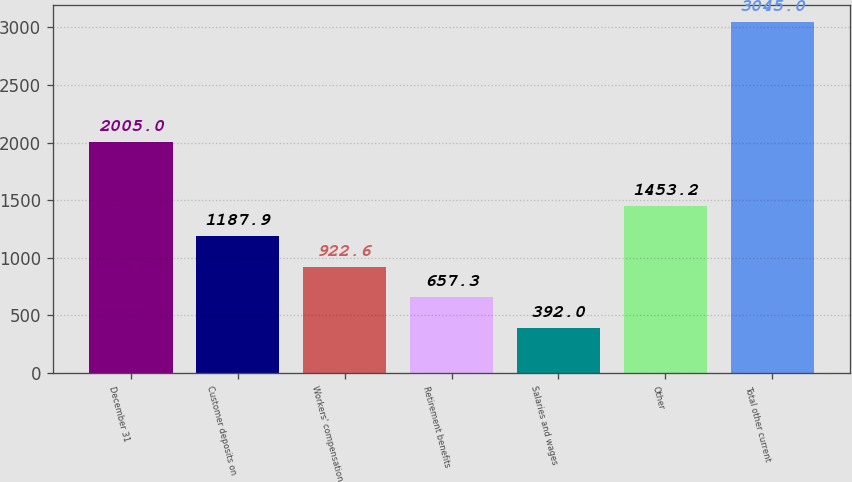<chart> <loc_0><loc_0><loc_500><loc_500><bar_chart><fcel>December 31<fcel>Customer deposits on<fcel>Workers' compensation<fcel>Retirement benefits<fcel>Salaries and wages<fcel>Other<fcel>Total other current<nl><fcel>2005<fcel>1187.9<fcel>922.6<fcel>657.3<fcel>392<fcel>1453.2<fcel>3045<nl></chart> 